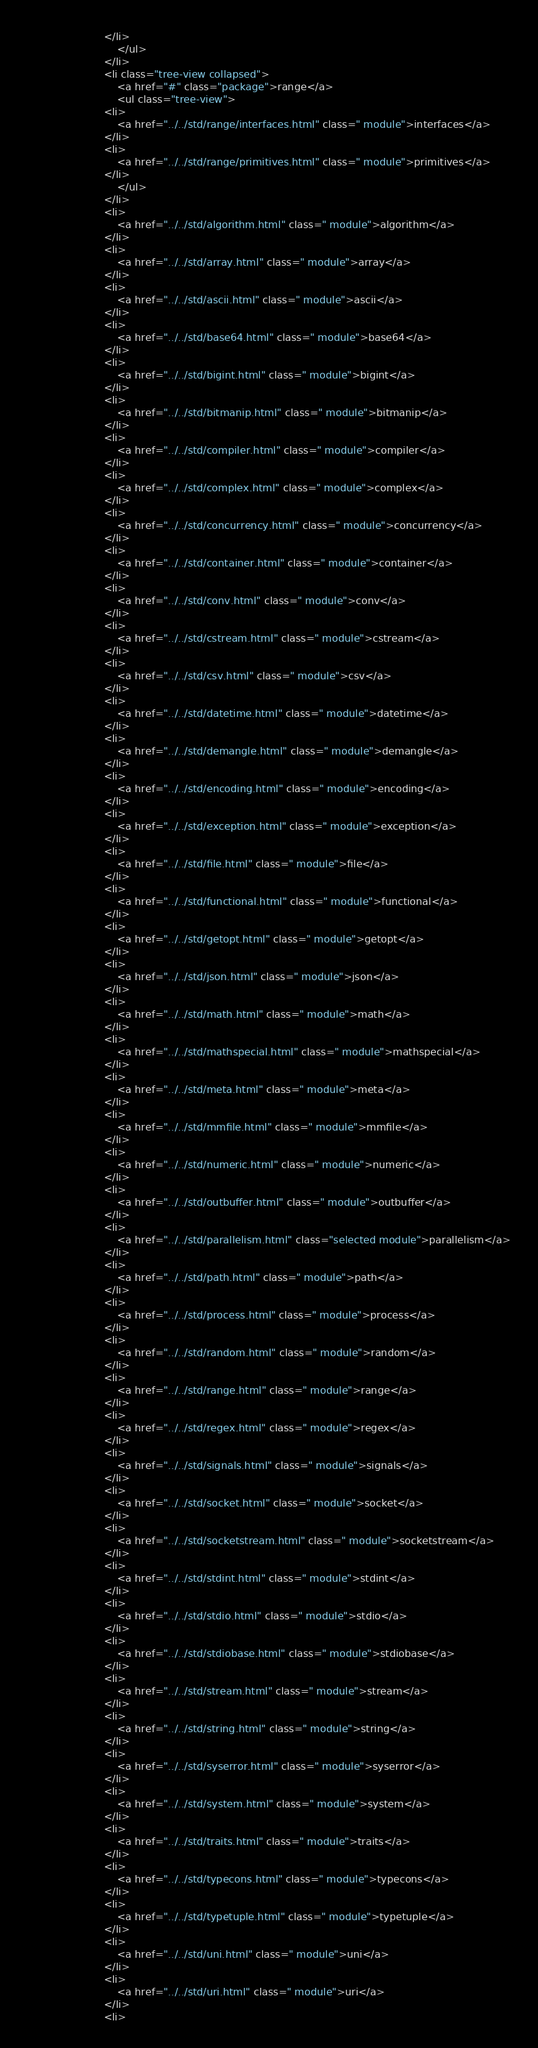Convert code to text. <code><loc_0><loc_0><loc_500><loc_500><_HTML_>						</li>
							</ul>
						</li>
						<li class="tree-view collapsed">
							<a href="#" class="package">range</a>
							<ul class="tree-view">
						<li>
							<a href="../../std/range/interfaces.html" class=" module">interfaces</a>
						</li>
						<li>
							<a href="../../std/range/primitives.html" class=" module">primitives</a>
						</li>
							</ul>
						</li>
						<li>
							<a href="../../std/algorithm.html" class=" module">algorithm</a>
						</li>
						<li>
							<a href="../../std/array.html" class=" module">array</a>
						</li>
						<li>
							<a href="../../std/ascii.html" class=" module">ascii</a>
						</li>
						<li>
							<a href="../../std/base64.html" class=" module">base64</a>
						</li>
						<li>
							<a href="../../std/bigint.html" class=" module">bigint</a>
						</li>
						<li>
							<a href="../../std/bitmanip.html" class=" module">bitmanip</a>
						</li>
						<li>
							<a href="../../std/compiler.html" class=" module">compiler</a>
						</li>
						<li>
							<a href="../../std/complex.html" class=" module">complex</a>
						</li>
						<li>
							<a href="../../std/concurrency.html" class=" module">concurrency</a>
						</li>
						<li>
							<a href="../../std/container.html" class=" module">container</a>
						</li>
						<li>
							<a href="../../std/conv.html" class=" module">conv</a>
						</li>
						<li>
							<a href="../../std/cstream.html" class=" module">cstream</a>
						</li>
						<li>
							<a href="../../std/csv.html" class=" module">csv</a>
						</li>
						<li>
							<a href="../../std/datetime.html" class=" module">datetime</a>
						</li>
						<li>
							<a href="../../std/demangle.html" class=" module">demangle</a>
						</li>
						<li>
							<a href="../../std/encoding.html" class=" module">encoding</a>
						</li>
						<li>
							<a href="../../std/exception.html" class=" module">exception</a>
						</li>
						<li>
							<a href="../../std/file.html" class=" module">file</a>
						</li>
						<li>
							<a href="../../std/functional.html" class=" module">functional</a>
						</li>
						<li>
							<a href="../../std/getopt.html" class=" module">getopt</a>
						</li>
						<li>
							<a href="../../std/json.html" class=" module">json</a>
						</li>
						<li>
							<a href="../../std/math.html" class=" module">math</a>
						</li>
						<li>
							<a href="../../std/mathspecial.html" class=" module">mathspecial</a>
						</li>
						<li>
							<a href="../../std/meta.html" class=" module">meta</a>
						</li>
						<li>
							<a href="../../std/mmfile.html" class=" module">mmfile</a>
						</li>
						<li>
							<a href="../../std/numeric.html" class=" module">numeric</a>
						</li>
						<li>
							<a href="../../std/outbuffer.html" class=" module">outbuffer</a>
						</li>
						<li>
							<a href="../../std/parallelism.html" class="selected module">parallelism</a>
						</li>
						<li>
							<a href="../../std/path.html" class=" module">path</a>
						</li>
						<li>
							<a href="../../std/process.html" class=" module">process</a>
						</li>
						<li>
							<a href="../../std/random.html" class=" module">random</a>
						</li>
						<li>
							<a href="../../std/range.html" class=" module">range</a>
						</li>
						<li>
							<a href="../../std/regex.html" class=" module">regex</a>
						</li>
						<li>
							<a href="../../std/signals.html" class=" module">signals</a>
						</li>
						<li>
							<a href="../../std/socket.html" class=" module">socket</a>
						</li>
						<li>
							<a href="../../std/socketstream.html" class=" module">socketstream</a>
						</li>
						<li>
							<a href="../../std/stdint.html" class=" module">stdint</a>
						</li>
						<li>
							<a href="../../std/stdio.html" class=" module">stdio</a>
						</li>
						<li>
							<a href="../../std/stdiobase.html" class=" module">stdiobase</a>
						</li>
						<li>
							<a href="../../std/stream.html" class=" module">stream</a>
						</li>
						<li>
							<a href="../../std/string.html" class=" module">string</a>
						</li>
						<li>
							<a href="../../std/syserror.html" class=" module">syserror</a>
						</li>
						<li>
							<a href="../../std/system.html" class=" module">system</a>
						</li>
						<li>
							<a href="../../std/traits.html" class=" module">traits</a>
						</li>
						<li>
							<a href="../../std/typecons.html" class=" module">typecons</a>
						</li>
						<li>
							<a href="../../std/typetuple.html" class=" module">typetuple</a>
						</li>
						<li>
							<a href="../../std/uni.html" class=" module">uni</a>
						</li>
						<li>
							<a href="../../std/uri.html" class=" module">uri</a>
						</li>
						<li></code> 